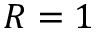<formula> <loc_0><loc_0><loc_500><loc_500>R = 1</formula> 